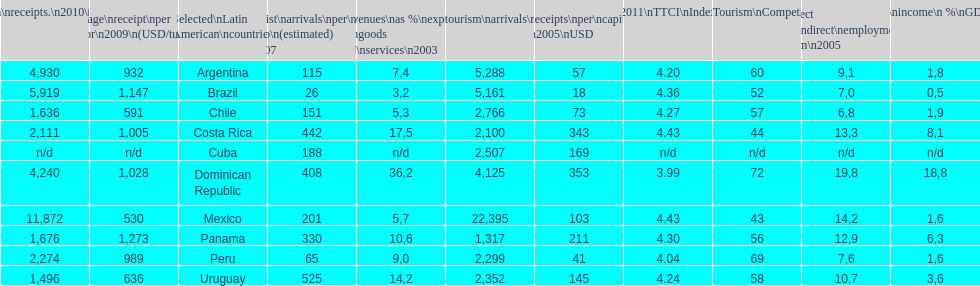How many dollars on average did brazil receive per tourist in 2009? 1,147. 